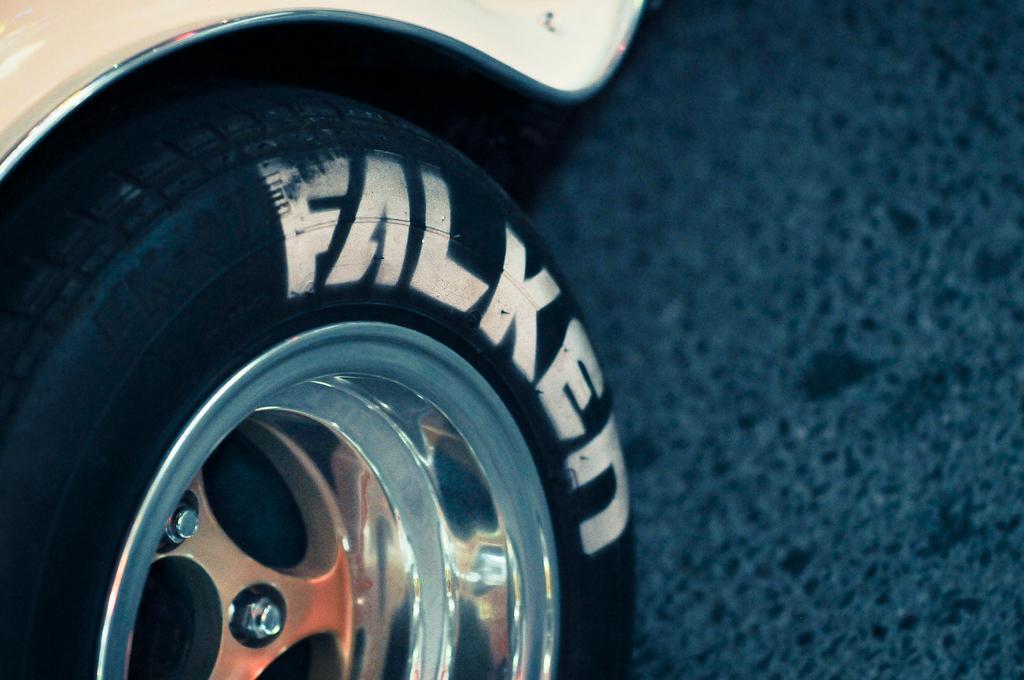Can you describe this image briefly? In this image I can see the wheel of the vehicle. I can see the vehicle is on the road. 